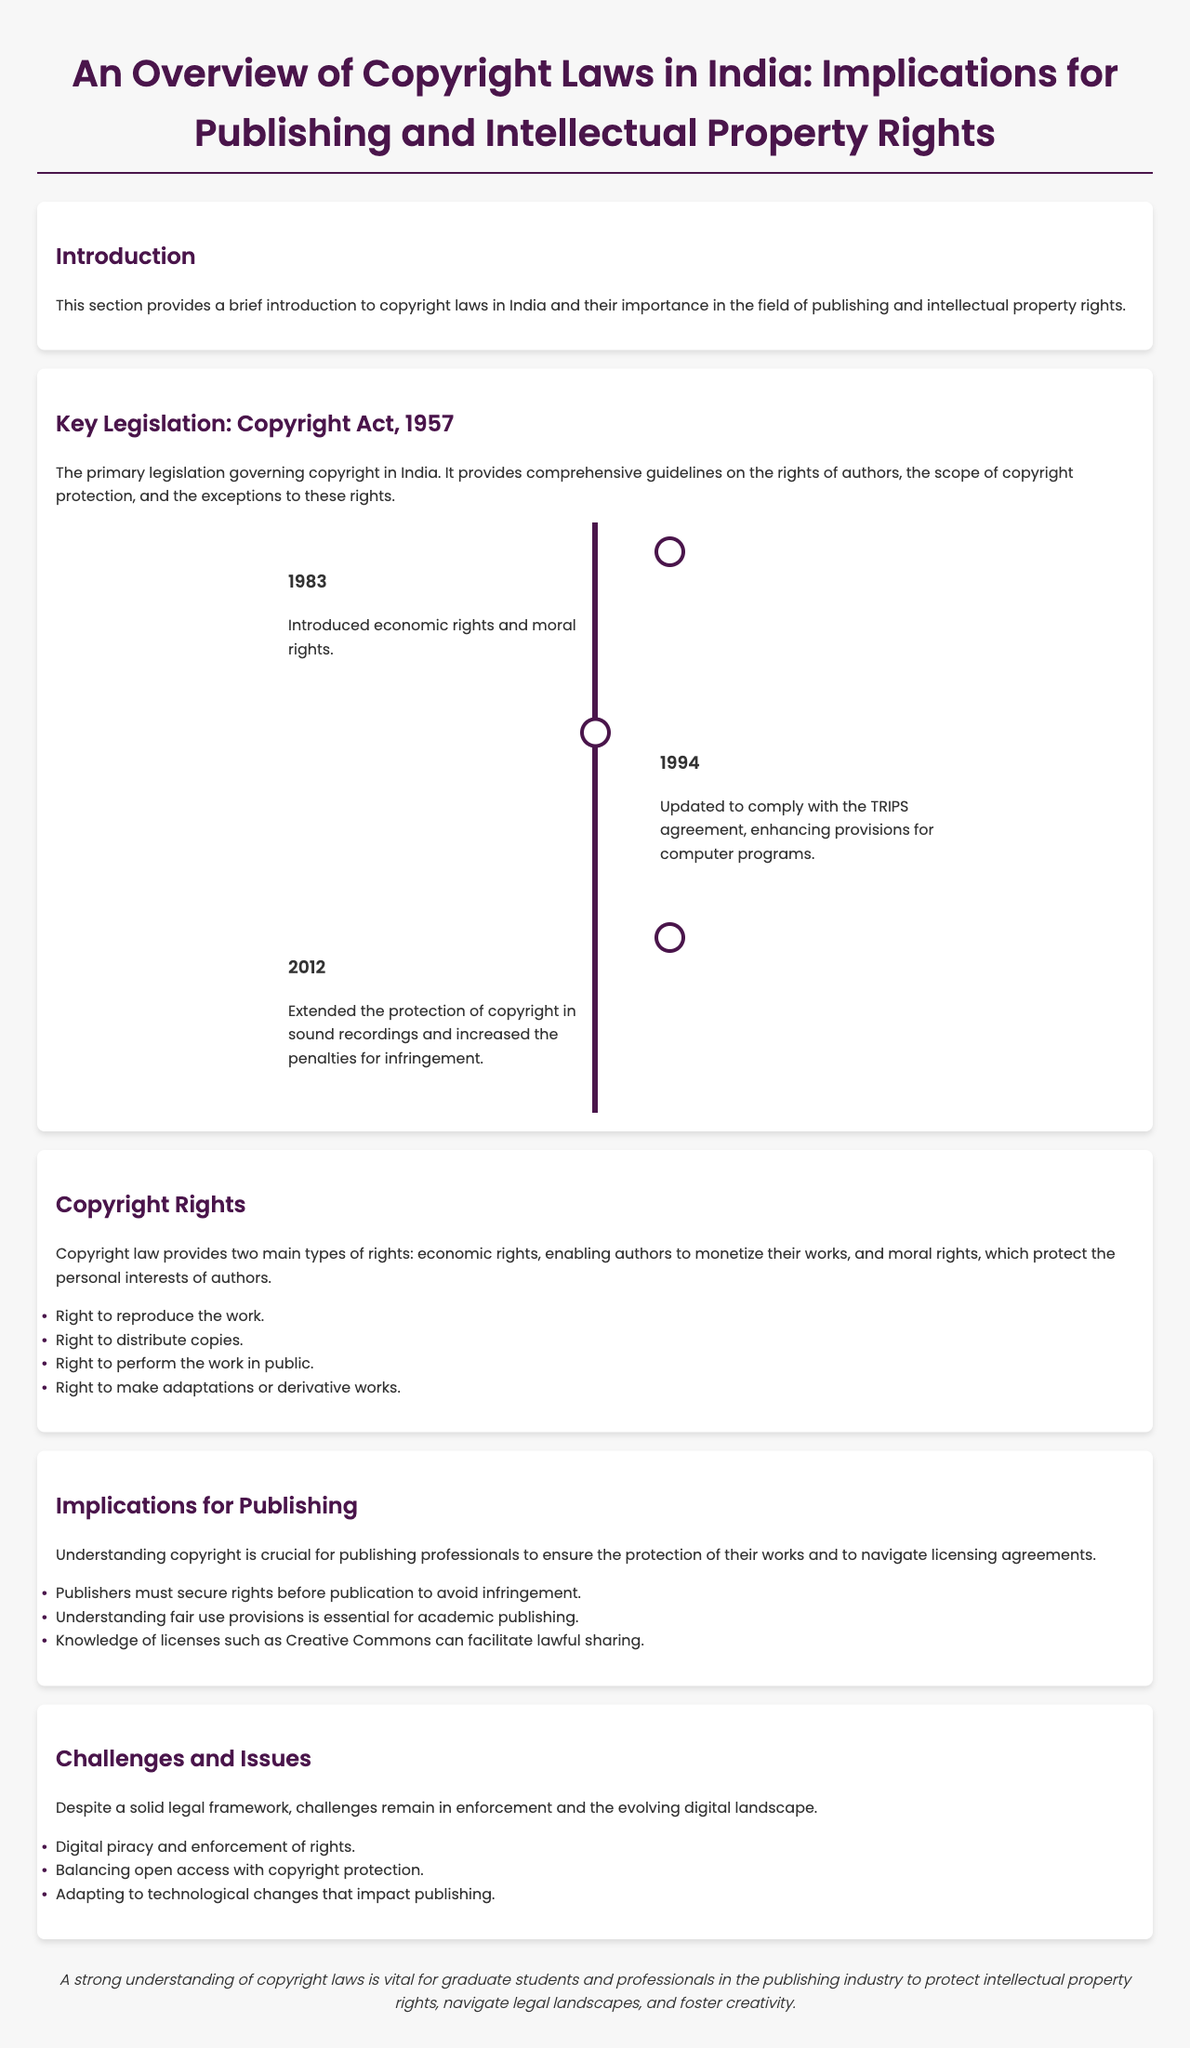What year was the Copyright Act enacted? The document states that the Copyright Act, which governs copyright in India, was enacted in 1957.
Answer: 1957 What are the two main types of rights provided by copyright law? According to the document, the two main types of rights are economic rights and moral rights.
Answer: Economic rights and moral rights Which year saw the introduction of economic rights and moral rights? The timeline in the document indicates that economic rights and moral rights were introduced in 1983.
Answer: 1983 What essential knowledge is required for academic publishing? The document mentions that understanding fair use provisions is essential for academic publishing.
Answer: Fair use provisions What is a significant challenge mentioned in the document regarding copyright? The document states that digital piracy and enforcement of rights is a significant challenge.
Answer: Digital piracy What type of rights must publishers secure before publication? The document emphasizes that publishers must secure rights before publication to avoid infringement.
Answer: Rights Which agreement did the Copyright Act update to comply with in 1994? The document specifies that the Copyright Act was updated to comply with the TRIPS agreement in 1994.
Answer: TRIPS agreement What is the main purpose of copyright laws according to the document? The introduction of the document states that copyright laws are important for protecting works in publishing and intellectual property rights.
Answer: Protecting works What legal framework challenge is noted in the document? The document describes the challenge of balancing open access with copyright protection as a noted issue.
Answer: Balancing open access 